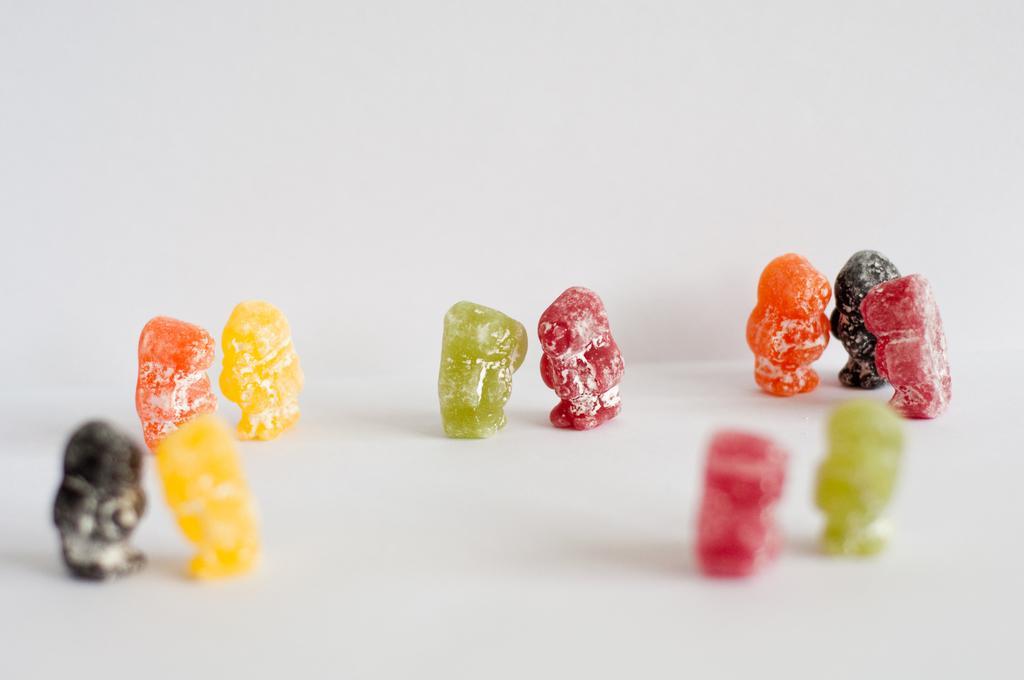Could you give a brief overview of what you see in this image? In this image I can see few candies which are yellow, orange, black, green, red and pink in color on the white colored surface. 